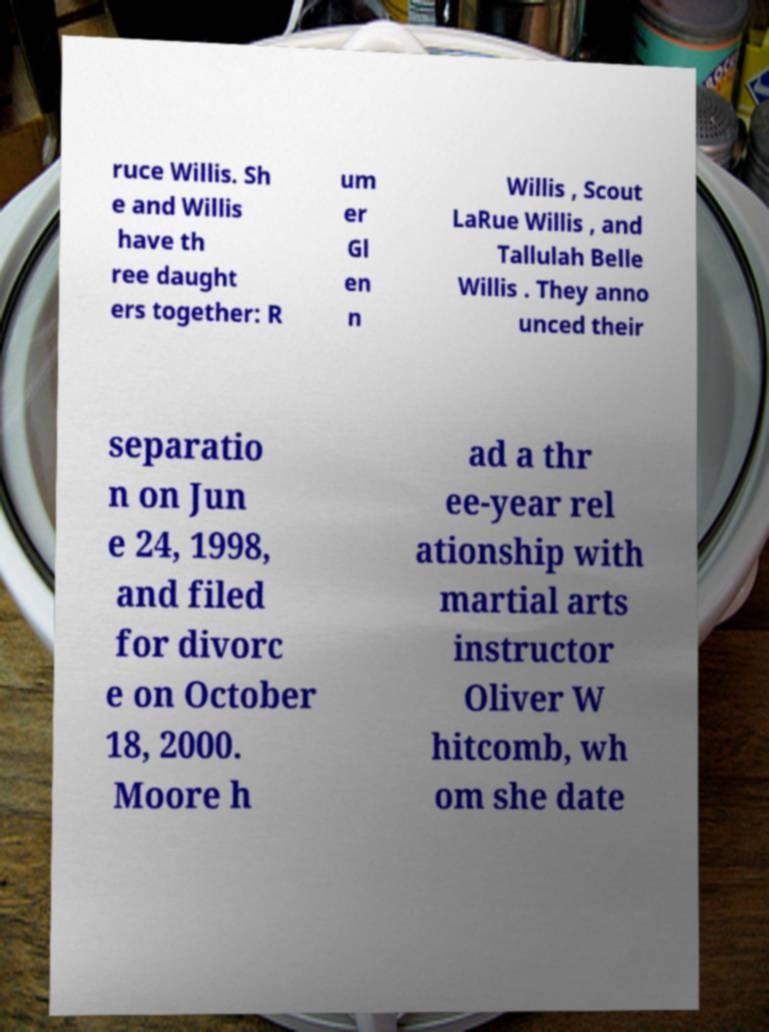Could you assist in decoding the text presented in this image and type it out clearly? ruce Willis. Sh e and Willis have th ree daught ers together: R um er Gl en n Willis , Scout LaRue Willis , and Tallulah Belle Willis . They anno unced their separatio n on Jun e 24, 1998, and filed for divorc e on October 18, 2000. Moore h ad a thr ee-year rel ationship with martial arts instructor Oliver W hitcomb, wh om she date 